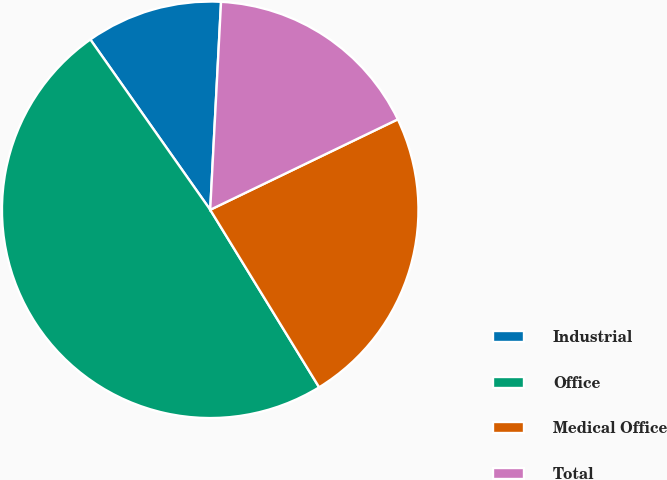<chart> <loc_0><loc_0><loc_500><loc_500><pie_chart><fcel>Industrial<fcel>Office<fcel>Medical Office<fcel>Total<nl><fcel>10.59%<fcel>49.0%<fcel>23.39%<fcel>17.02%<nl></chart> 